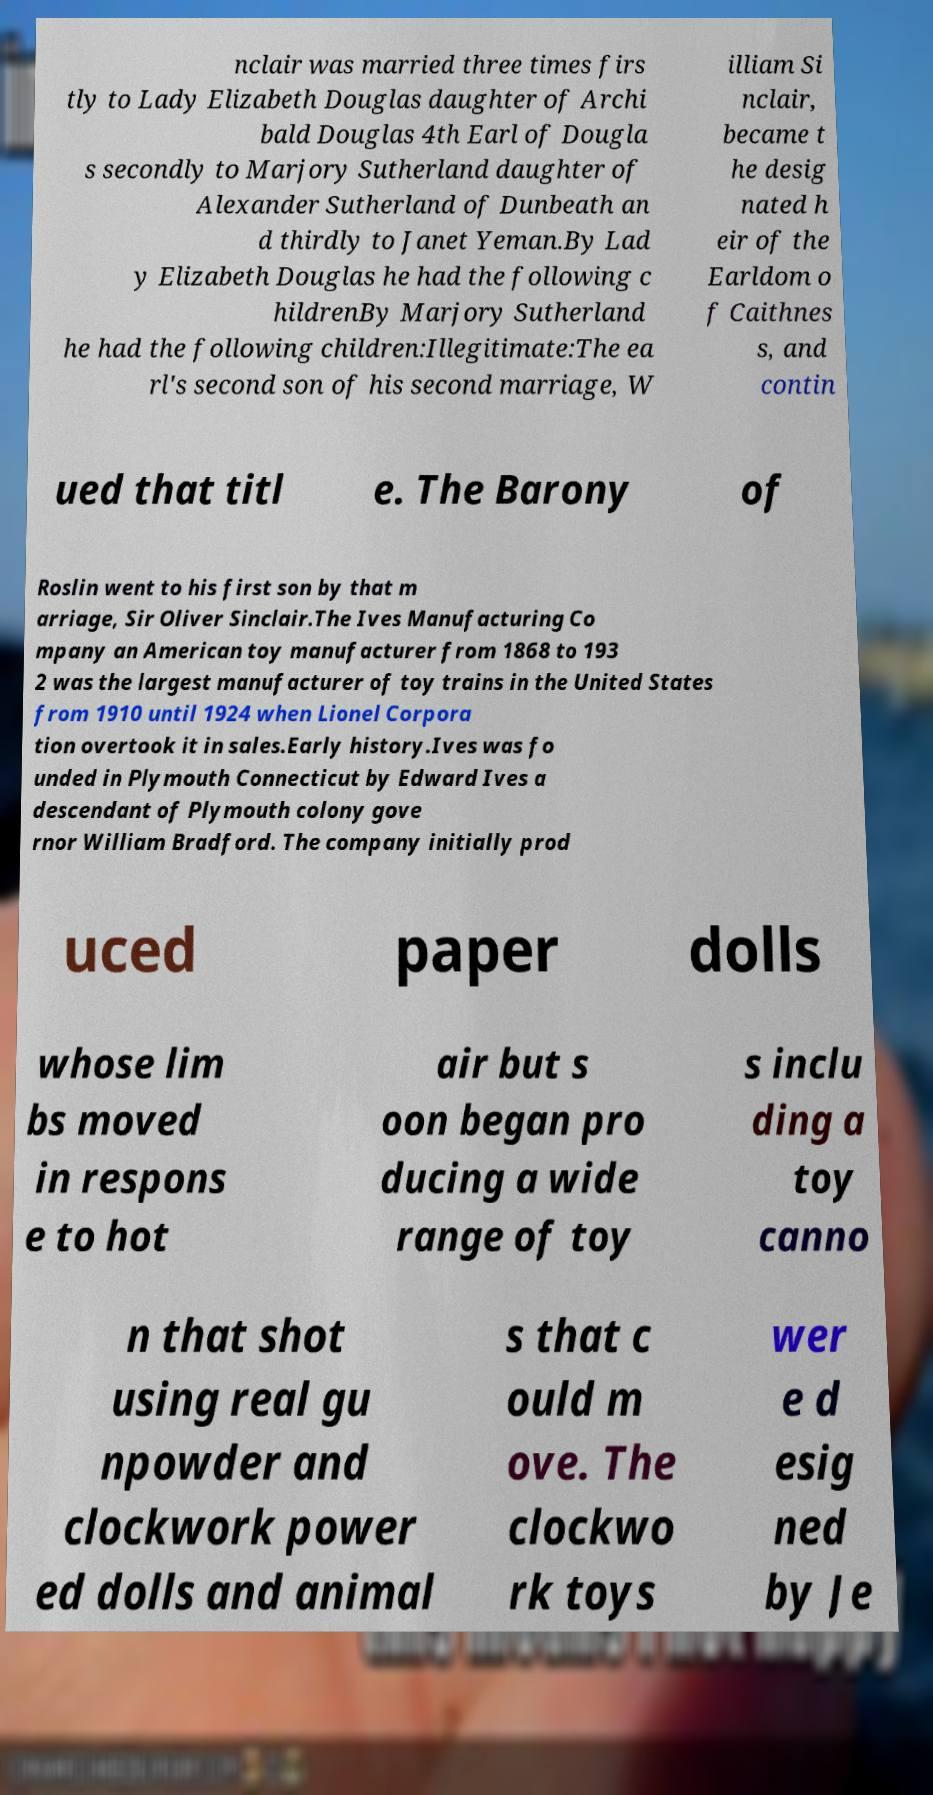Could you extract and type out the text from this image? nclair was married three times firs tly to Lady Elizabeth Douglas daughter of Archi bald Douglas 4th Earl of Dougla s secondly to Marjory Sutherland daughter of Alexander Sutherland of Dunbeath an d thirdly to Janet Yeman.By Lad y Elizabeth Douglas he had the following c hildrenBy Marjory Sutherland he had the following children:Illegitimate:The ea rl's second son of his second marriage, W illiam Si nclair, became t he desig nated h eir of the Earldom o f Caithnes s, and contin ued that titl e. The Barony of Roslin went to his first son by that m arriage, Sir Oliver Sinclair.The Ives Manufacturing Co mpany an American toy manufacturer from 1868 to 193 2 was the largest manufacturer of toy trains in the United States from 1910 until 1924 when Lionel Corpora tion overtook it in sales.Early history.Ives was fo unded in Plymouth Connecticut by Edward Ives a descendant of Plymouth colony gove rnor William Bradford. The company initially prod uced paper dolls whose lim bs moved in respons e to hot air but s oon began pro ducing a wide range of toy s inclu ding a toy canno n that shot using real gu npowder and clockwork power ed dolls and animal s that c ould m ove. The clockwo rk toys wer e d esig ned by Je 